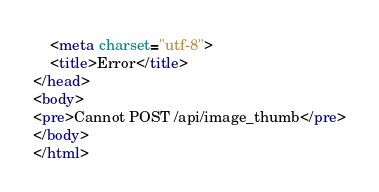Convert code to text. <code><loc_0><loc_0><loc_500><loc_500><_HTML_>    <meta charset="utf-8">
    <title>Error</title>
</head>
<body>
<pre>Cannot POST /api/image_thumb</pre>
</body>
</html>
</code> 